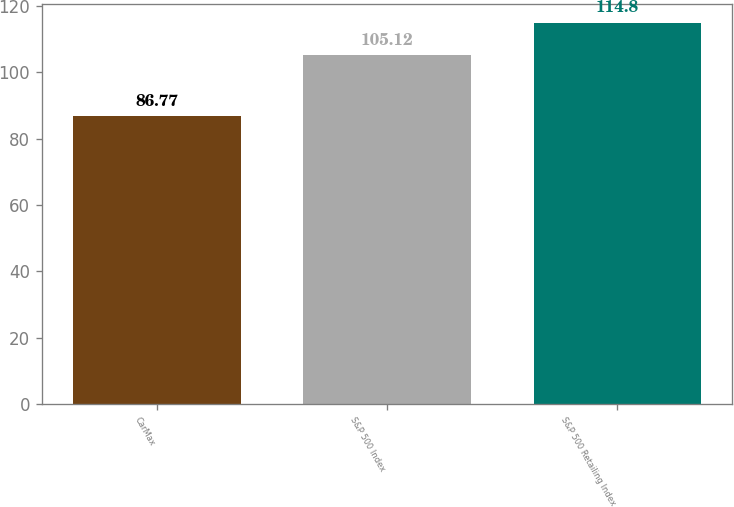<chart> <loc_0><loc_0><loc_500><loc_500><bar_chart><fcel>CarMax<fcel>S&P 500 Index<fcel>S&P 500 Retailing Index<nl><fcel>86.77<fcel>105.12<fcel>114.8<nl></chart> 